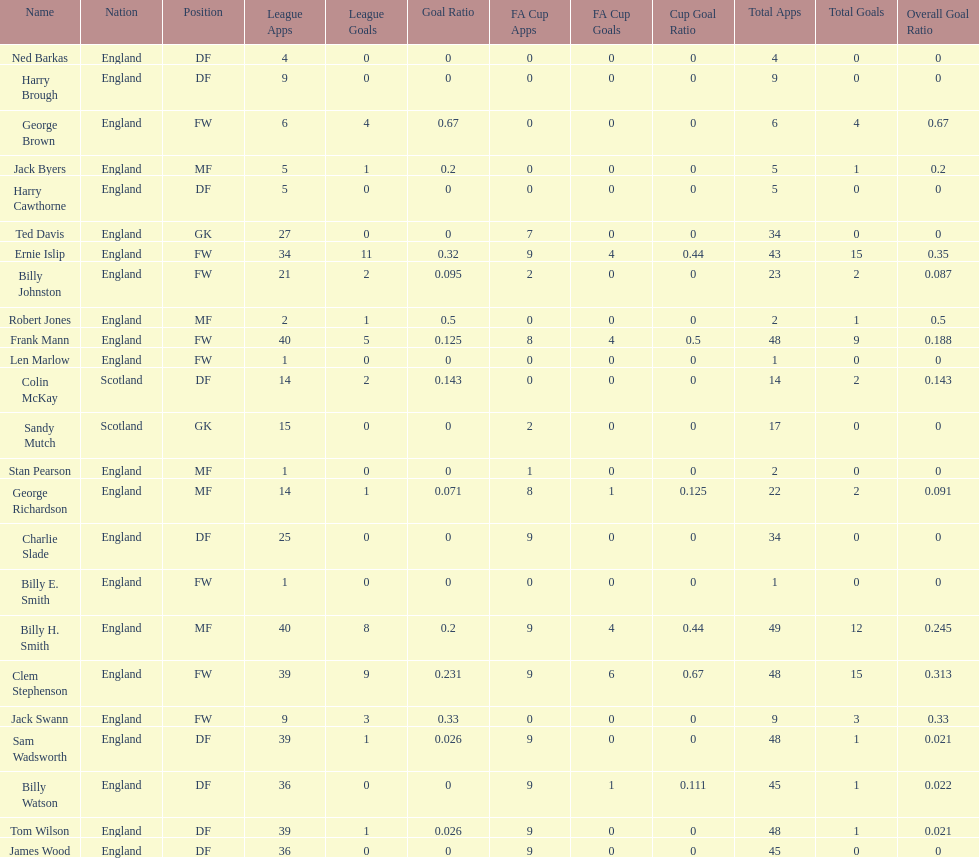Could you parse the entire table? {'header': ['Name', 'Nation', 'Position', 'League Apps', 'League Goals', 'Goal Ratio', 'FA Cup Apps', 'FA Cup Goals', 'Cup Goal Ratio', 'Total Apps', 'Total Goals', 'Overall Goal Ratio'], 'rows': [['Ned Barkas', 'England', 'DF', '4', '0', '0', '0', '0', '0', '4', '0', '0'], ['Harry Brough', 'England', 'DF', '9', '0', '0', '0', '0', '0', '9', '0', '0'], ['George Brown', 'England', 'FW', '6', '4', '0.67', '0', '0', '0', '6', '4', '0.67'], ['Jack Byers', 'England', 'MF', '5', '1', '0.2', '0', '0', '0', '5', '1', '0.2'], ['Harry Cawthorne', 'England', 'DF', '5', '0', '0', '0', '0', '0', '5', '0', '0'], ['Ted Davis', 'England', 'GK', '27', '0', '0', '7', '0', '0', '34', '0', '0'], ['Ernie Islip', 'England', 'FW', '34', '11', '0.32', '9', '4', '0.44', '43', '15', '0.35'], ['Billy Johnston', 'England', 'FW', '21', '2', '0.095', '2', '0', '0', '23', '2', '0.087'], ['Robert Jones', 'England', 'MF', '2', '1', '0.5', '0', '0', '0', '2', '1', '0.5'], ['Frank Mann', 'England', 'FW', '40', '5', '0.125', '8', '4', '0.5', '48', '9', '0.188'], ['Len Marlow', 'England', 'FW', '1', '0', '0', '0', '0', '0', '1', '0', '0'], ['Colin McKay', 'Scotland', 'DF', '14', '2', '0.143', '0', '0', '0', '14', '2', '0.143'], ['Sandy Mutch', 'Scotland', 'GK', '15', '0', '0', '2', '0', '0', '17', '0', '0'], ['Stan Pearson', 'England', 'MF', '1', '0', '0', '1', '0', '0', '2', '0', '0'], ['George Richardson', 'England', 'MF', '14', '1', '0.071', '8', '1', '0.125', '22', '2', '0.091'], ['Charlie Slade', 'England', 'DF', '25', '0', '0', '9', '0', '0', '34', '0', '0'], ['Billy E. Smith', 'England', 'FW', '1', '0', '0', '0', '0', '0', '1', '0', '0'], ['Billy H. Smith', 'England', 'MF', '40', '8', '0.2', '9', '4', '0.44', '49', '12', '0.245'], ['Clem Stephenson', 'England', 'FW', '39', '9', '0.231', '9', '6', '0.67', '48', '15', '0.313'], ['Jack Swann', 'England', 'FW', '9', '3', '0.33', '0', '0', '0', '9', '3', '0.33'], ['Sam Wadsworth', 'England', 'DF', '39', '1', '0.026', '9', '0', '0', '48', '1', '0.021'], ['Billy Watson', 'England', 'DF', '36', '0', '0', '9', '1', '0.111', '45', '1', '0.022'], ['Tom Wilson', 'England', 'DF', '39', '1', '0.026', '9', '0', '0', '48', '1', '0.021'], ['James Wood', 'England', 'DF', '36', '0', '0', '9', '0', '0', '45', '0', '0']]} The least number of total appearances 1. 